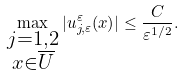<formula> <loc_0><loc_0><loc_500><loc_500>\max _ { \substack { j = 1 , 2 \\ x \in \overline { U } } } | u _ { j , \varepsilon } ^ { \varepsilon } ( x ) | \leq \frac { C } { \varepsilon ^ { 1 / 2 } } .</formula> 